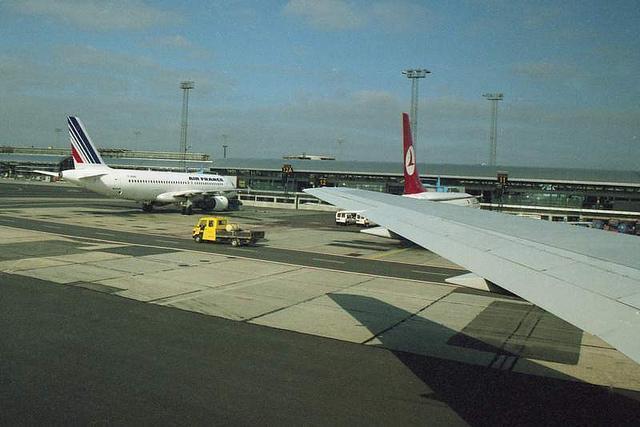How many airplanes can be seen?
Give a very brief answer. 2. How many people are wearing orange shirts?
Give a very brief answer. 0. 